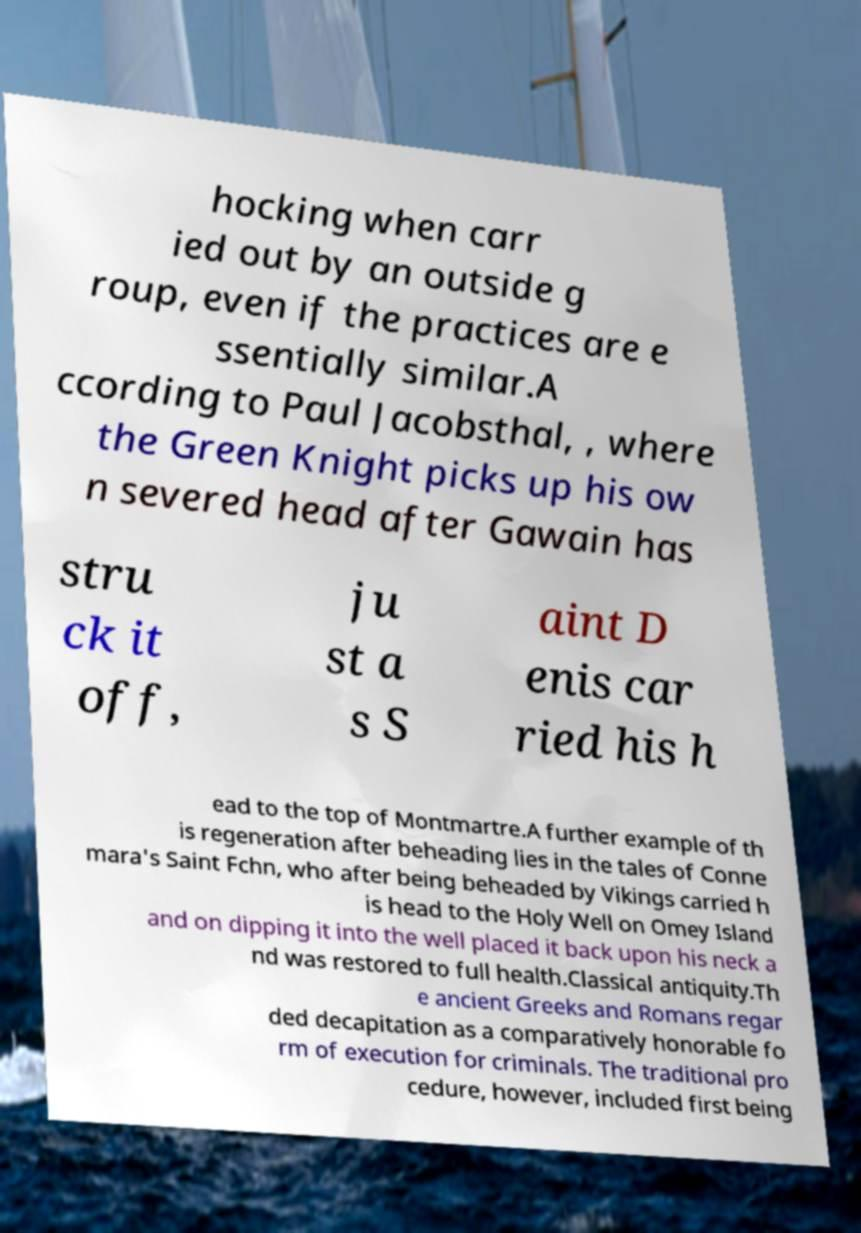I need the written content from this picture converted into text. Can you do that? hocking when carr ied out by an outside g roup, even if the practices are e ssentially similar.A ccording to Paul Jacobsthal, , where the Green Knight picks up his ow n severed head after Gawain has stru ck it off, ju st a s S aint D enis car ried his h ead to the top of Montmartre.A further example of th is regeneration after beheading lies in the tales of Conne mara's Saint Fchn, who after being beheaded by Vikings carried h is head to the Holy Well on Omey Island and on dipping it into the well placed it back upon his neck a nd was restored to full health.Classical antiquity.Th e ancient Greeks and Romans regar ded decapitation as a comparatively honorable fo rm of execution for criminals. The traditional pro cedure, however, included first being 